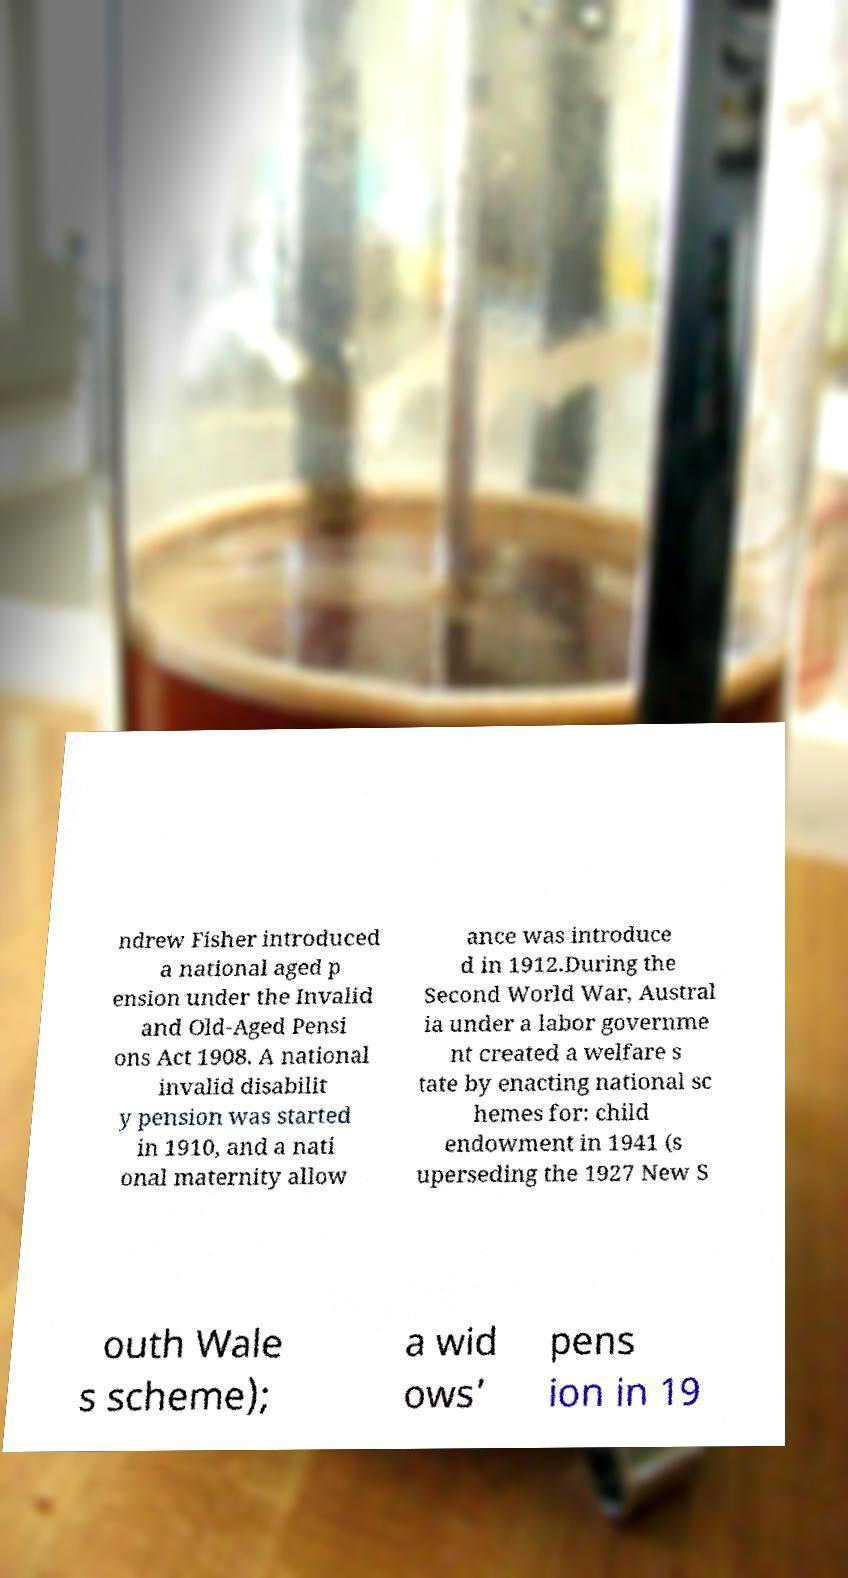Can you accurately transcribe the text from the provided image for me? ndrew Fisher introduced a national aged p ension under the Invalid and Old-Aged Pensi ons Act 1908. A national invalid disabilit y pension was started in 1910, and a nati onal maternity allow ance was introduce d in 1912.During the Second World War, Austral ia under a labor governme nt created a welfare s tate by enacting national sc hemes for: child endowment in 1941 (s uperseding the 1927 New S outh Wale s scheme); a wid ows’ pens ion in 19 